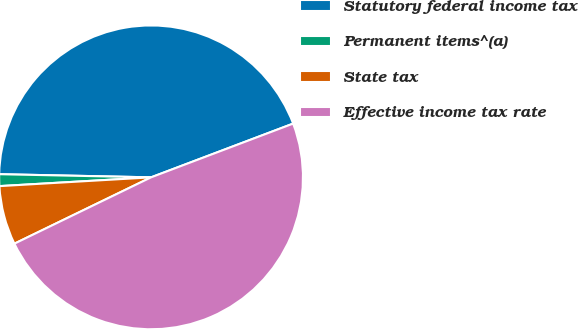Convert chart. <chart><loc_0><loc_0><loc_500><loc_500><pie_chart><fcel>Statutory federal income tax<fcel>Permanent items^(a)<fcel>State tax<fcel>Effective income tax rate<nl><fcel>43.91%<fcel>1.25%<fcel>6.27%<fcel>48.56%<nl></chart> 